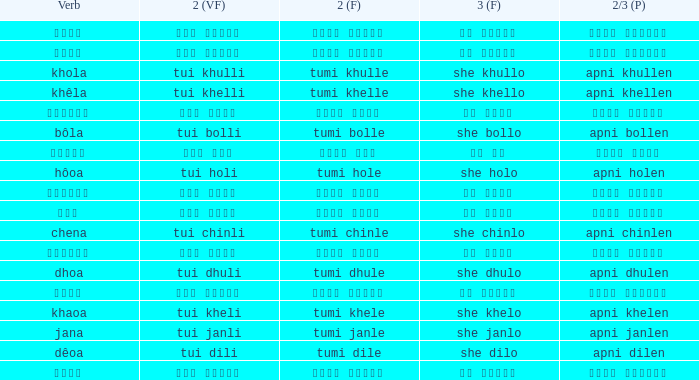What is the verb for তুমি খেলে? খাওয়া. 